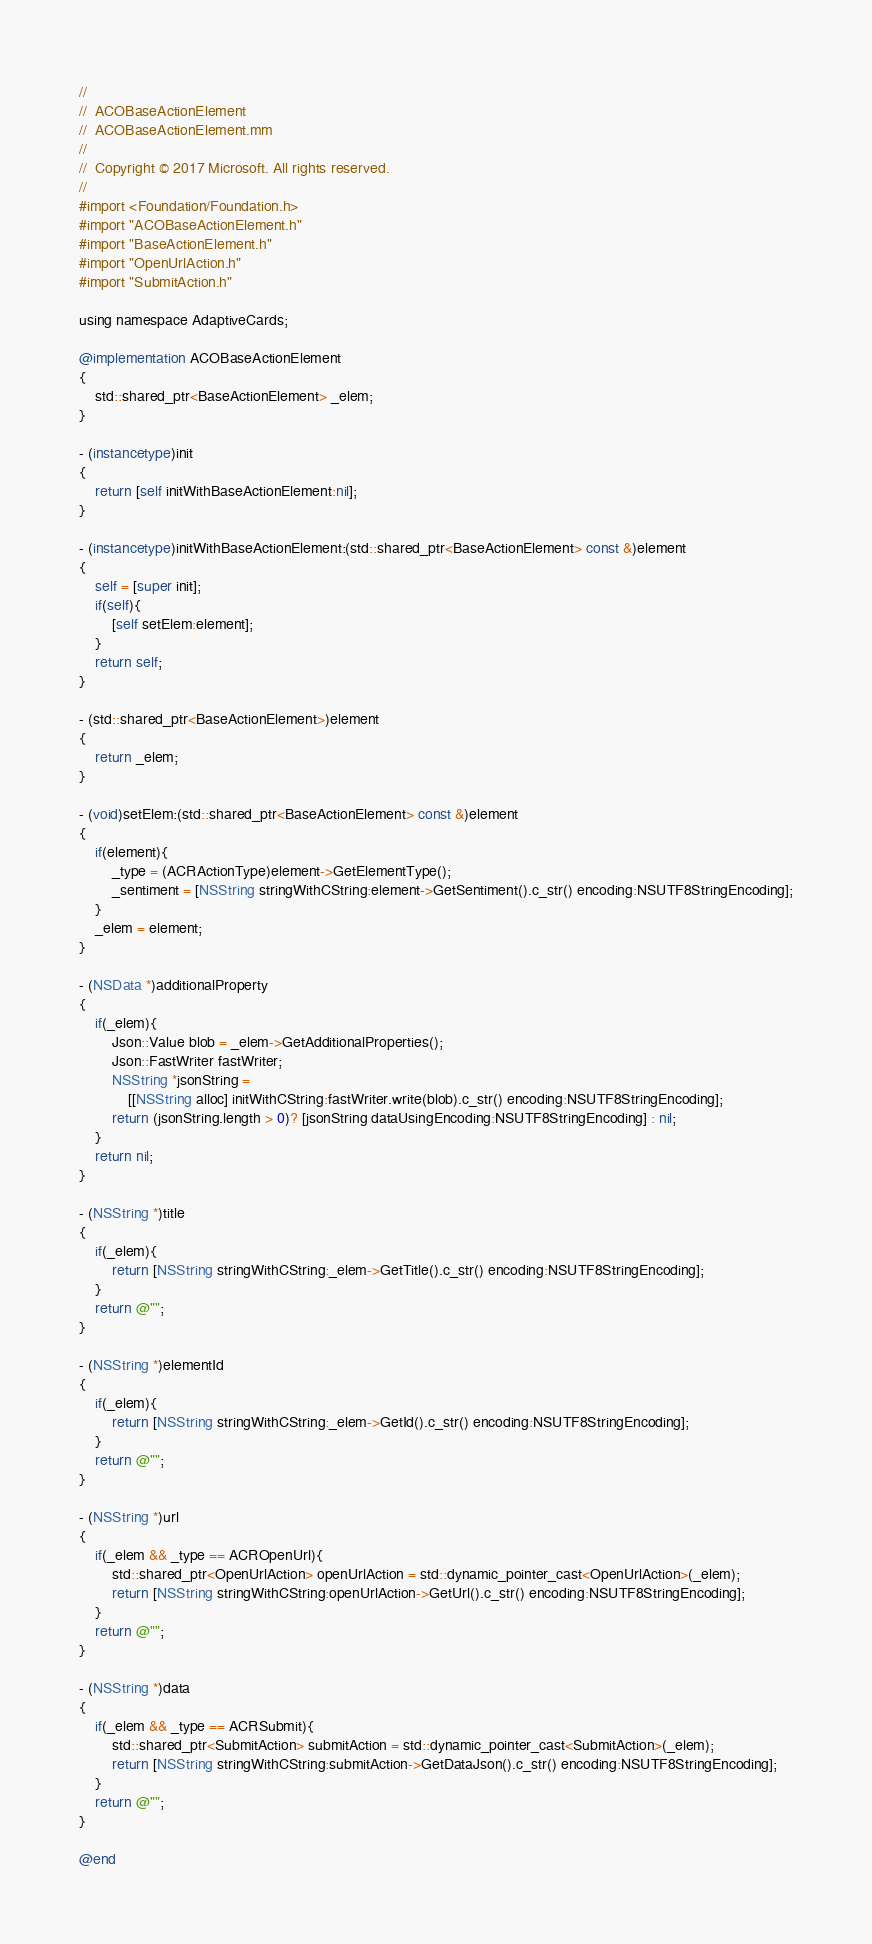<code> <loc_0><loc_0><loc_500><loc_500><_ObjectiveC_>//
//  ACOBaseActionElement
//  ACOBaseActionElement.mm
//
//  Copyright © 2017 Microsoft. All rights reserved.
//
#import <Foundation/Foundation.h>
#import "ACOBaseActionElement.h"
#import "BaseActionElement.h"
#import "OpenUrlAction.h"
#import "SubmitAction.h"

using namespace AdaptiveCards;

@implementation ACOBaseActionElement
{
    std::shared_ptr<BaseActionElement> _elem;
}

- (instancetype)init
{
    return [self initWithBaseActionElement:nil];
}

- (instancetype)initWithBaseActionElement:(std::shared_ptr<BaseActionElement> const &)element
{
    self = [super init];
    if(self){
        [self setElem:element];
    }
    return self;
}

- (std::shared_ptr<BaseActionElement>)element
{
    return _elem;
}

- (void)setElem:(std::shared_ptr<BaseActionElement> const &)element
{
    if(element){
        _type = (ACRActionType)element->GetElementType();
        _sentiment = [NSString stringWithCString:element->GetSentiment().c_str() encoding:NSUTF8StringEncoding];
    }
    _elem = element;
}

- (NSData *)additionalProperty
{
    if(_elem){
        Json::Value blob = _elem->GetAdditionalProperties();
        Json::FastWriter fastWriter;
        NSString *jsonString =
            [[NSString alloc] initWithCString:fastWriter.write(blob).c_str() encoding:NSUTF8StringEncoding];
        return (jsonString.length > 0)? [jsonString dataUsingEncoding:NSUTF8StringEncoding] : nil;
    }
    return nil;
}

- (NSString *)title
{
    if(_elem){
        return [NSString stringWithCString:_elem->GetTitle().c_str() encoding:NSUTF8StringEncoding];
    }
    return @"";
}

- (NSString *)elementId
{
    if(_elem){
        return [NSString stringWithCString:_elem->GetId().c_str() encoding:NSUTF8StringEncoding];
    }
    return @"";
}

- (NSString *)url
{
    if(_elem && _type == ACROpenUrl){
        std::shared_ptr<OpenUrlAction> openUrlAction = std::dynamic_pointer_cast<OpenUrlAction>(_elem);
        return [NSString stringWithCString:openUrlAction->GetUrl().c_str() encoding:NSUTF8StringEncoding];
    }
    return @"";
}

- (NSString *)data
{
    if(_elem && _type == ACRSubmit){
        std::shared_ptr<SubmitAction> submitAction = std::dynamic_pointer_cast<SubmitAction>(_elem);
        return [NSString stringWithCString:submitAction->GetDataJson().c_str() encoding:NSUTF8StringEncoding];
    }
    return @"";
}

@end
</code> 